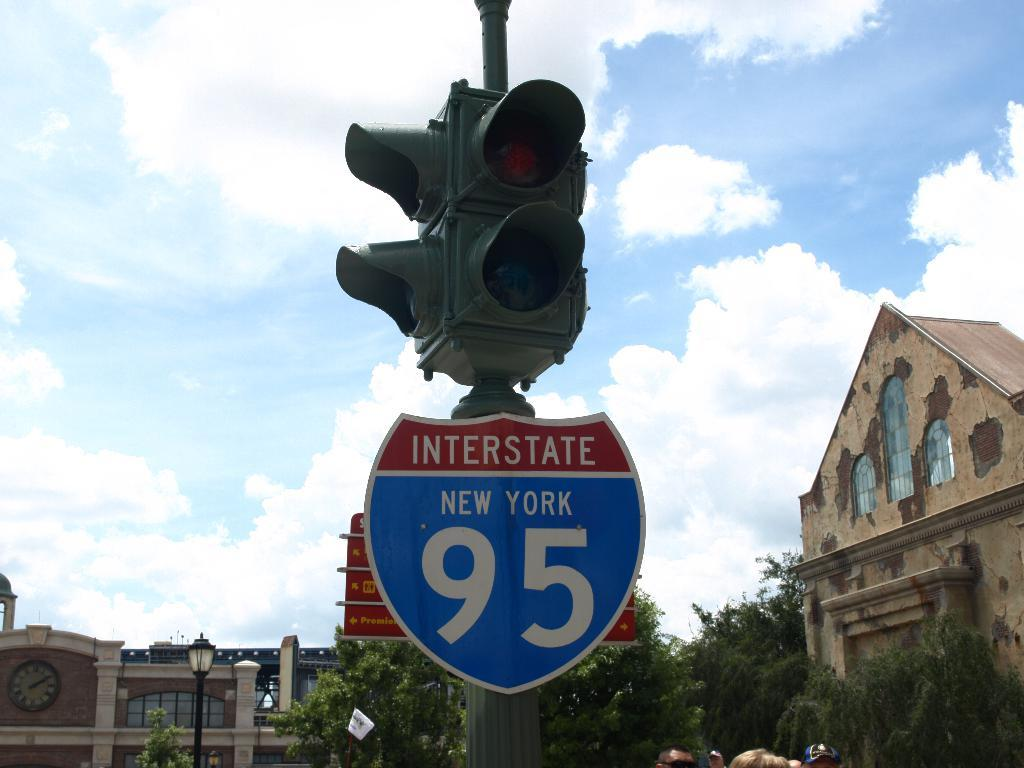<image>
Present a compact description of the photo's key features. the number 95 on a sign that is below some lights 